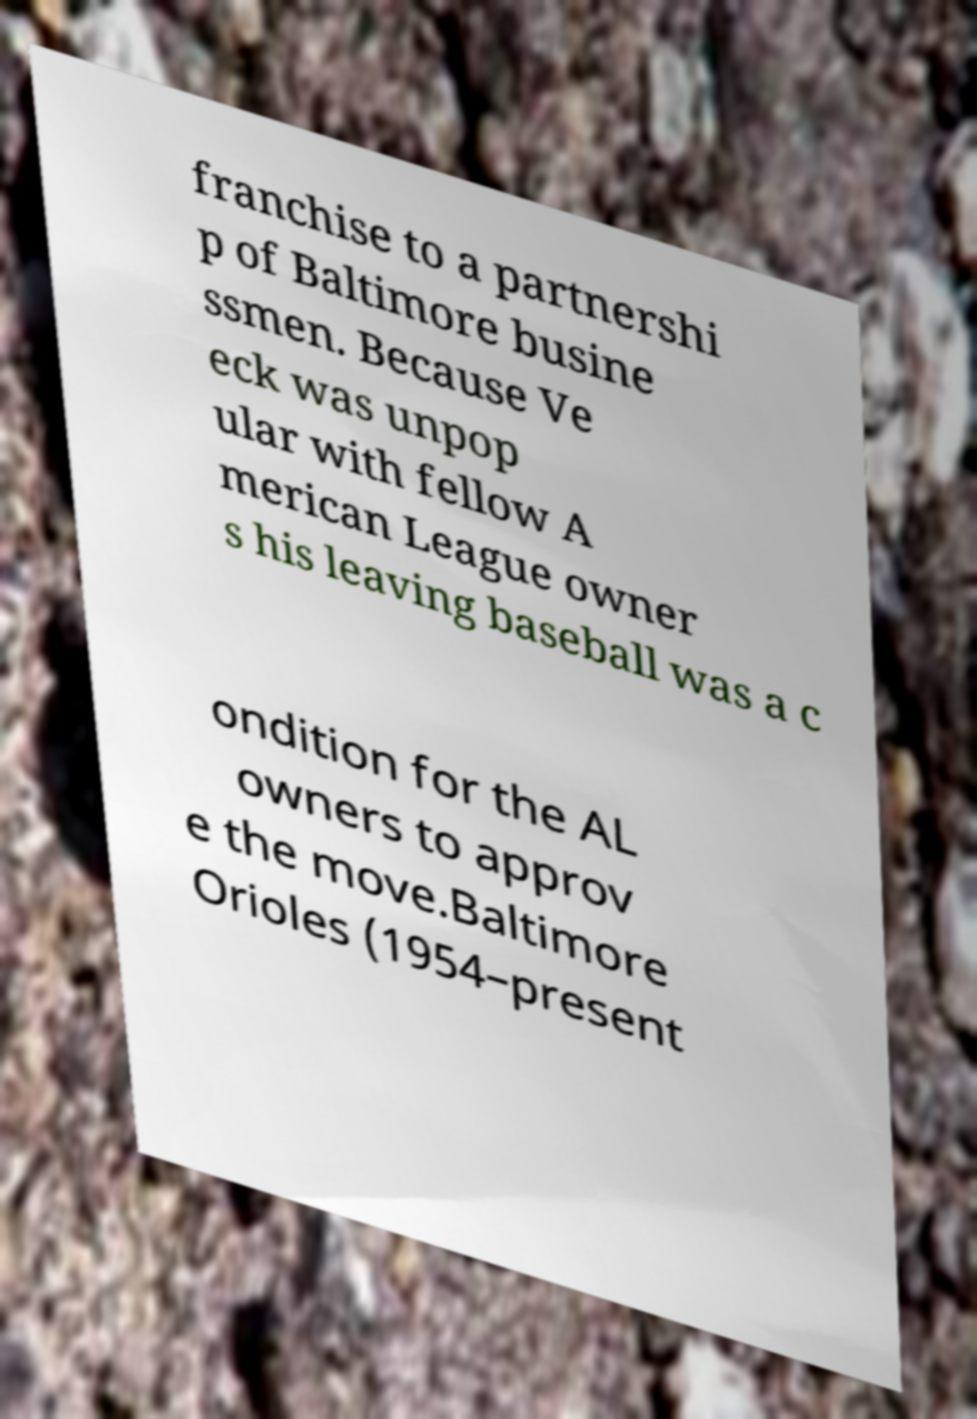Can you read and provide the text displayed in the image?This photo seems to have some interesting text. Can you extract and type it out for me? franchise to a partnershi p of Baltimore busine ssmen. Because Ve eck was unpop ular with fellow A merican League owner s his leaving baseball was a c ondition for the AL owners to approv e the move.Baltimore Orioles (1954–present 